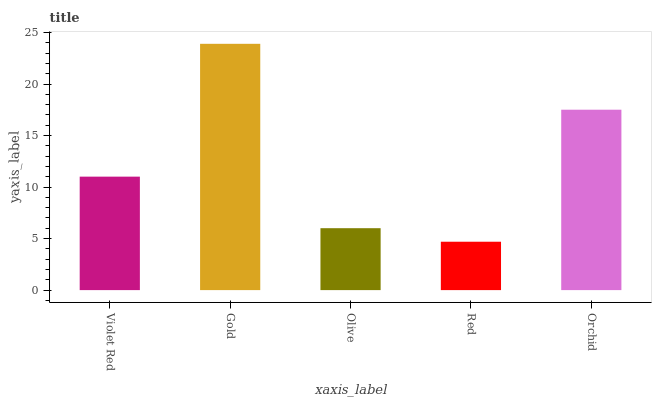Is Red the minimum?
Answer yes or no. Yes. Is Gold the maximum?
Answer yes or no. Yes. Is Olive the minimum?
Answer yes or no. No. Is Olive the maximum?
Answer yes or no. No. Is Gold greater than Olive?
Answer yes or no. Yes. Is Olive less than Gold?
Answer yes or no. Yes. Is Olive greater than Gold?
Answer yes or no. No. Is Gold less than Olive?
Answer yes or no. No. Is Violet Red the high median?
Answer yes or no. Yes. Is Violet Red the low median?
Answer yes or no. Yes. Is Gold the high median?
Answer yes or no. No. Is Orchid the low median?
Answer yes or no. No. 